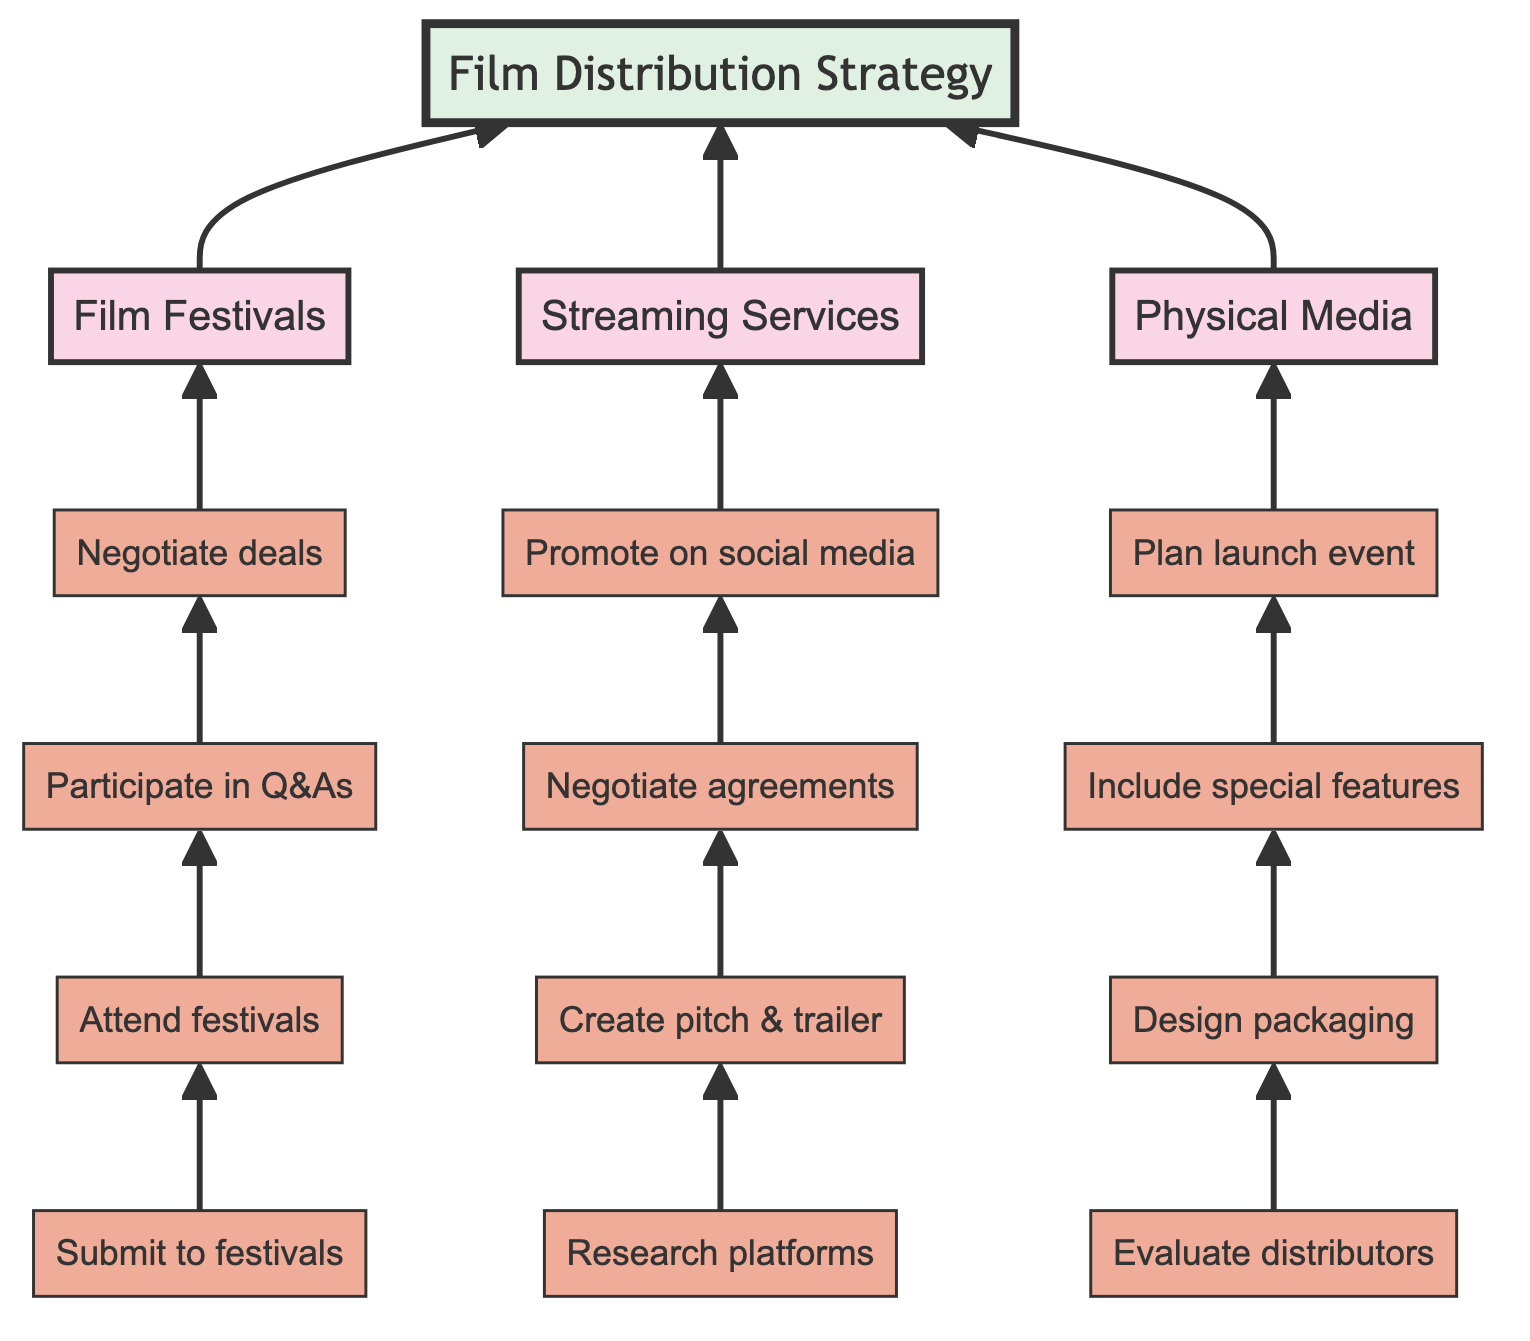what are the three main channels listed in the diagram? The diagram outlines three main channels: Film Festivals, Streaming Services, and Physical Media. These are distinct pathways for film distribution strategies.
Answer: Film Festivals, Streaming Services, Physical Media how many steps are included under the Film Festivals channel? The Film Festivals channel has four steps: 1) Submit film to festivals, 2) Attend festivals, 3) Participate in Q&As, 4) Negotiate deals. Counting these, we see the number of steps is four.
Answer: 4 what is the first step in the Streaming Services pathway? The first step in the Streaming Services pathway is to research suitable platforms. This can be found as the initial action under this channel, which establishes the foundation for further steps.
Answer: Research platforms what is the last step in the Physical Media flow? The last step in the Physical Media flow is to plan a launch event. This is the final action that completes the distribution strategy for this channel, illustrating the promotional aspect of physical media sales.
Answer: Plan launch event which step comes after negotiating licensing agreements in the Streaming Services channel? After negotiating licensing agreements in the Streaming Services channel, the next step is to promote the film through social media and targeted marketing campaigns. This step follows the agreements, indicating a focus on audience engagement.
Answer: Promote on social media how many total steps does the Film Distribution Strategy encompass? The Film Distribution Strategy comprises a total of twelve steps: 4 from Film Festivals, 4 from Streaming Services, and 4 from Physical Media, making it a collective total of twelve steps across all channels.
Answer: 12 what is the purpose of attending festivals in the Film Festivals channel? The purpose of attending festivals is to network with industry professionals and audiences. This action is aimed at building connections and gaining visibility for the film.
Answer: Network with industry professionals and audiences which channel involves designing cover art and packaging? The channel that involves designing cover art and packaging is Physical Media. This step is crucial for appealing visually to potential buyers or renters in the physical sales market.
Answer: Physical Media what is the second step in the Physical Media pathway? The second step in the Physical Media pathway is to design packaging. This follows the evaluation of potential distributors and is essential for aligning visual identity with the film's aesthetic.
Answer: Design packaging 